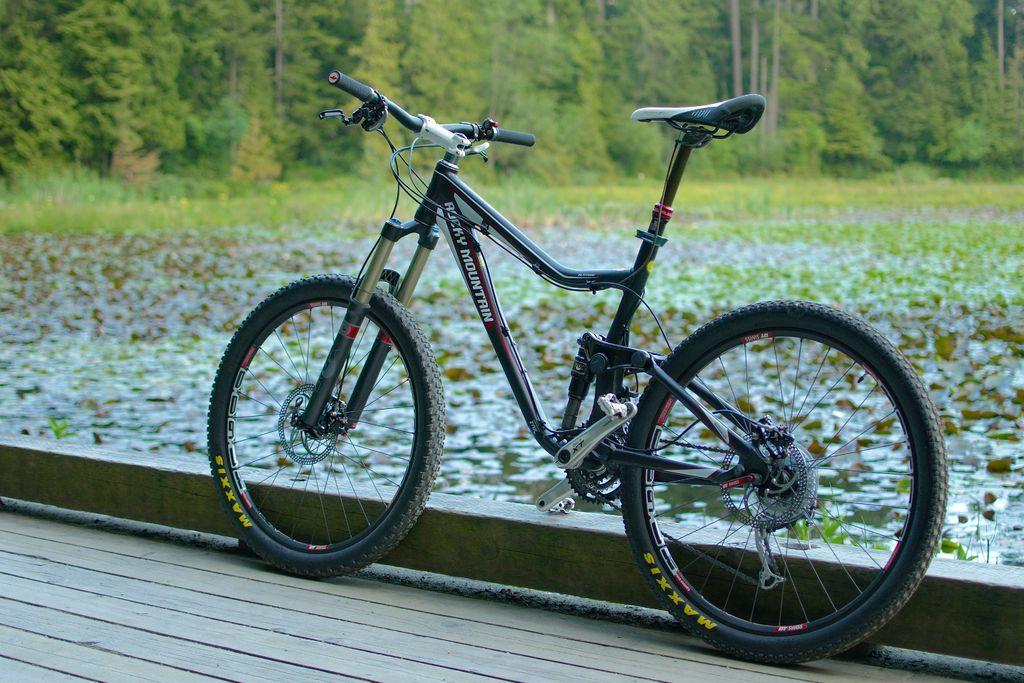How would you summarize this image in a sentence or two? In this picture there is a bicycle on the wooden floor and there is text on the bicycle. At the back there are trees and there are plants on the water. 